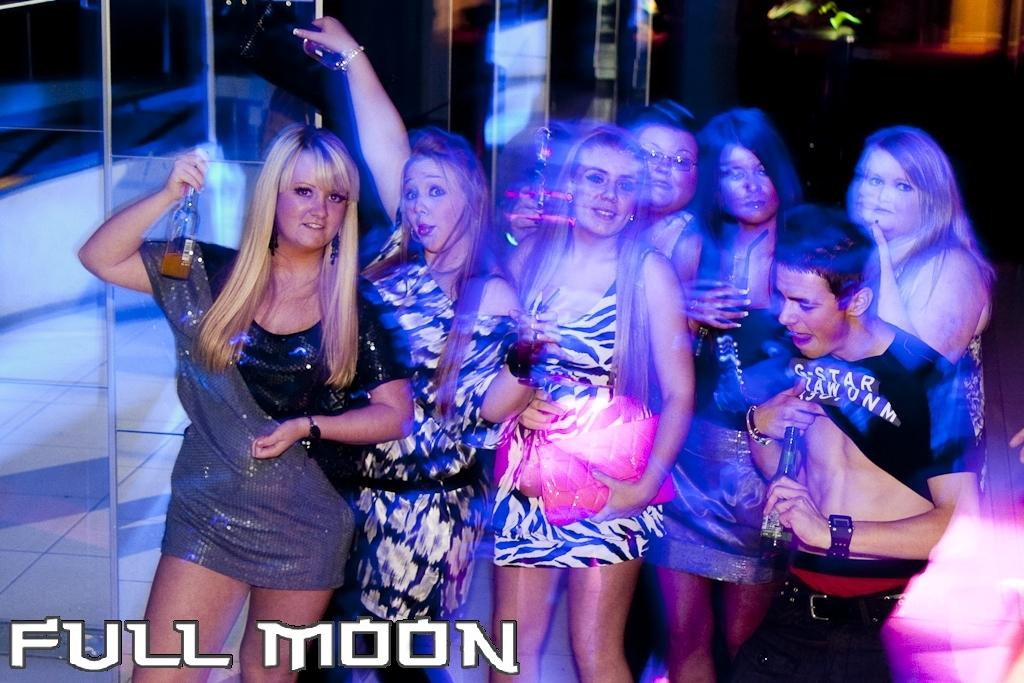How many individuals are present in the image? There are girls and a boy in the image, making a total of three individuals. What are the individuals holding in the image? The individuals are standing and holding wine bottles. What phrase is written under the scene in the image? The phrase "full moon" is written under the scene. What type of haircut does the boy have in the image? There is no information about the boy's haircut in the image. What symbol of peace is present in the image? There is no symbol of peace present in the image. 